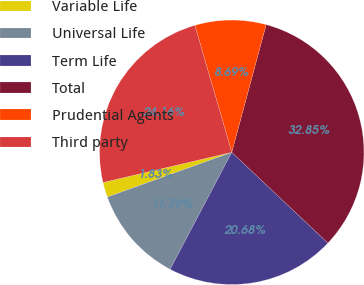<chart> <loc_0><loc_0><loc_500><loc_500><pie_chart><fcel>Variable Life<fcel>Universal Life<fcel>Term Life<fcel>Total<fcel>Prudential Agents<fcel>Third party<nl><fcel>1.83%<fcel>11.79%<fcel>20.68%<fcel>32.85%<fcel>8.69%<fcel>24.16%<nl></chart> 